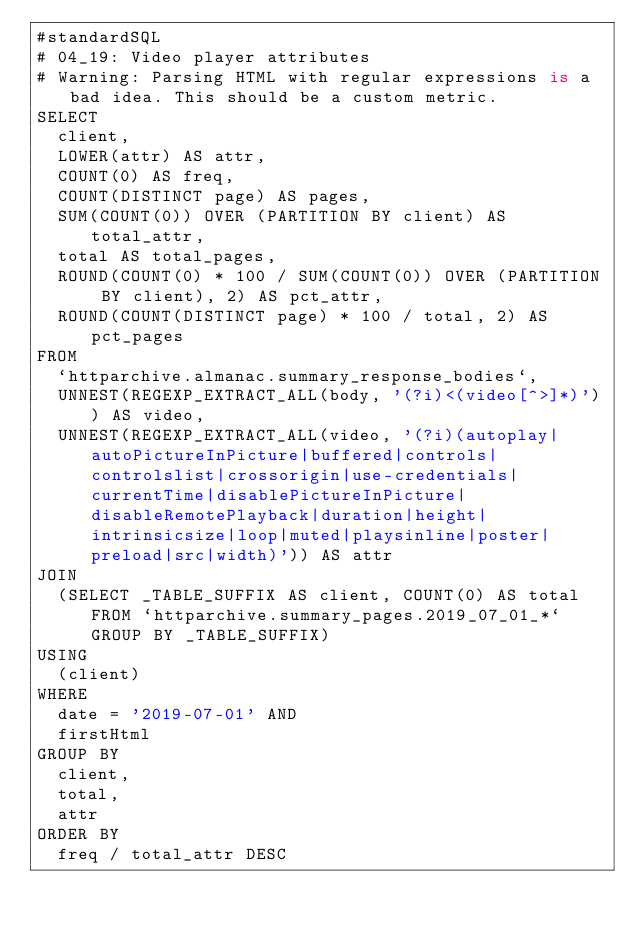Convert code to text. <code><loc_0><loc_0><loc_500><loc_500><_SQL_>#standardSQL
# 04_19: Video player attributes
# Warning: Parsing HTML with regular expressions is a bad idea. This should be a custom metric.
SELECT
  client,
  LOWER(attr) AS attr,
  COUNT(0) AS freq,
  COUNT(DISTINCT page) AS pages,
  SUM(COUNT(0)) OVER (PARTITION BY client) AS total_attr,
  total AS total_pages,
  ROUND(COUNT(0) * 100 / SUM(COUNT(0)) OVER (PARTITION BY client), 2) AS pct_attr,
  ROUND(COUNT(DISTINCT page) * 100 / total, 2) AS pct_pages
FROM
  `httparchive.almanac.summary_response_bodies`,
  UNNEST(REGEXP_EXTRACT_ALL(body, '(?i)<(video[^>]*)')) AS video,
  UNNEST(REGEXP_EXTRACT_ALL(video, '(?i)(autoplay|autoPictureInPicture|buffered|controls|controlslist|crossorigin|use-credentials|currentTime|disablePictureInPicture|disableRemotePlayback|duration|height|intrinsicsize|loop|muted|playsinline|poster|preload|src|width)')) AS attr
JOIN
  (SELECT _TABLE_SUFFIX AS client, COUNT(0) AS total FROM `httparchive.summary_pages.2019_07_01_*` GROUP BY _TABLE_SUFFIX)
USING
  (client)
WHERE
  date = '2019-07-01' AND
  firstHtml
GROUP BY
  client,
  total,
  attr
ORDER BY
  freq / total_attr DESC
</code> 